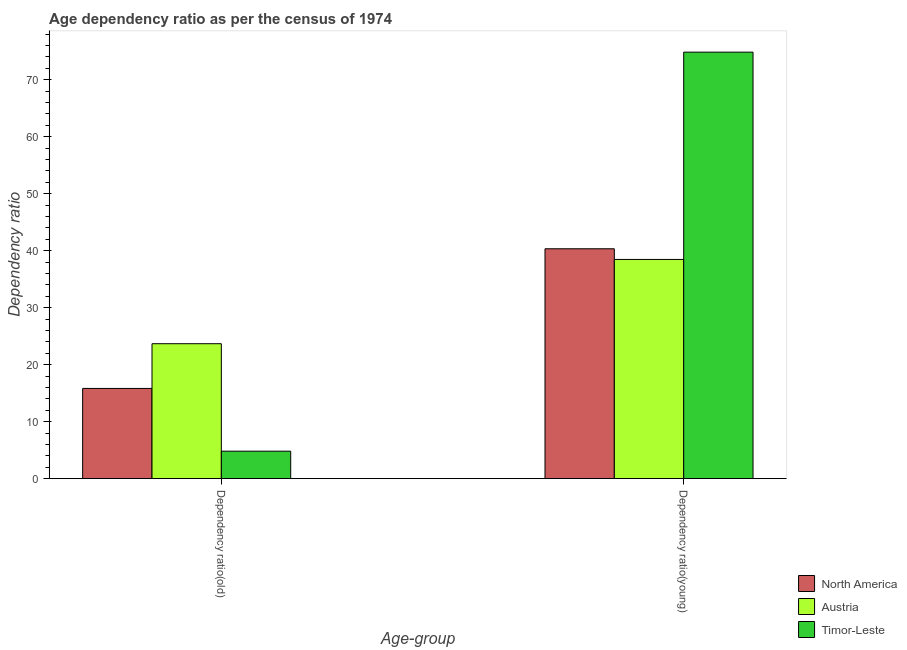How many different coloured bars are there?
Ensure brevity in your answer.  3. How many groups of bars are there?
Offer a terse response. 2. What is the label of the 2nd group of bars from the left?
Offer a terse response. Dependency ratio(young). What is the age dependency ratio(old) in North America?
Your answer should be compact. 15.83. Across all countries, what is the maximum age dependency ratio(young)?
Ensure brevity in your answer.  74.84. Across all countries, what is the minimum age dependency ratio(young)?
Keep it short and to the point. 38.46. What is the total age dependency ratio(old) in the graph?
Keep it short and to the point. 44.31. What is the difference between the age dependency ratio(old) in North America and that in Timor-Leste?
Provide a short and direct response. 11.01. What is the difference between the age dependency ratio(old) in Austria and the age dependency ratio(young) in Timor-Leste?
Give a very brief answer. -51.16. What is the average age dependency ratio(old) per country?
Your response must be concise. 14.77. What is the difference between the age dependency ratio(young) and age dependency ratio(old) in Austria?
Offer a terse response. 14.79. What is the ratio of the age dependency ratio(old) in Timor-Leste to that in North America?
Give a very brief answer. 0.3. Is the age dependency ratio(young) in Timor-Leste less than that in North America?
Provide a succinct answer. No. In how many countries, is the age dependency ratio(young) greater than the average age dependency ratio(young) taken over all countries?
Your answer should be compact. 1. What does the 1st bar from the right in Dependency ratio(old) represents?
Ensure brevity in your answer.  Timor-Leste. How many countries are there in the graph?
Your answer should be compact. 3. What is the difference between two consecutive major ticks on the Y-axis?
Ensure brevity in your answer.  10. Does the graph contain grids?
Your answer should be very brief. No. What is the title of the graph?
Your answer should be compact. Age dependency ratio as per the census of 1974. What is the label or title of the X-axis?
Your answer should be compact. Age-group. What is the label or title of the Y-axis?
Your answer should be very brief. Dependency ratio. What is the Dependency ratio in North America in Dependency ratio(old)?
Provide a succinct answer. 15.83. What is the Dependency ratio of Austria in Dependency ratio(old)?
Provide a succinct answer. 23.67. What is the Dependency ratio in Timor-Leste in Dependency ratio(old)?
Your answer should be compact. 4.81. What is the Dependency ratio in North America in Dependency ratio(young)?
Make the answer very short. 40.33. What is the Dependency ratio in Austria in Dependency ratio(young)?
Offer a terse response. 38.46. What is the Dependency ratio of Timor-Leste in Dependency ratio(young)?
Offer a terse response. 74.84. Across all Age-group, what is the maximum Dependency ratio of North America?
Keep it short and to the point. 40.33. Across all Age-group, what is the maximum Dependency ratio of Austria?
Ensure brevity in your answer.  38.46. Across all Age-group, what is the maximum Dependency ratio of Timor-Leste?
Give a very brief answer. 74.84. Across all Age-group, what is the minimum Dependency ratio of North America?
Your answer should be compact. 15.83. Across all Age-group, what is the minimum Dependency ratio in Austria?
Offer a very short reply. 23.67. Across all Age-group, what is the minimum Dependency ratio in Timor-Leste?
Give a very brief answer. 4.81. What is the total Dependency ratio in North America in the graph?
Your answer should be compact. 56.16. What is the total Dependency ratio of Austria in the graph?
Your answer should be very brief. 62.13. What is the total Dependency ratio of Timor-Leste in the graph?
Your response must be concise. 79.65. What is the difference between the Dependency ratio of North America in Dependency ratio(old) and that in Dependency ratio(young)?
Offer a terse response. -24.5. What is the difference between the Dependency ratio in Austria in Dependency ratio(old) and that in Dependency ratio(young)?
Your response must be concise. -14.79. What is the difference between the Dependency ratio in Timor-Leste in Dependency ratio(old) and that in Dependency ratio(young)?
Keep it short and to the point. -70.02. What is the difference between the Dependency ratio in North America in Dependency ratio(old) and the Dependency ratio in Austria in Dependency ratio(young)?
Ensure brevity in your answer.  -22.63. What is the difference between the Dependency ratio of North America in Dependency ratio(old) and the Dependency ratio of Timor-Leste in Dependency ratio(young)?
Your answer should be compact. -59.01. What is the difference between the Dependency ratio of Austria in Dependency ratio(old) and the Dependency ratio of Timor-Leste in Dependency ratio(young)?
Provide a succinct answer. -51.16. What is the average Dependency ratio in North America per Age-group?
Offer a terse response. 28.08. What is the average Dependency ratio of Austria per Age-group?
Keep it short and to the point. 31.07. What is the average Dependency ratio in Timor-Leste per Age-group?
Give a very brief answer. 39.82. What is the difference between the Dependency ratio of North America and Dependency ratio of Austria in Dependency ratio(old)?
Your answer should be very brief. -7.85. What is the difference between the Dependency ratio in North America and Dependency ratio in Timor-Leste in Dependency ratio(old)?
Make the answer very short. 11.01. What is the difference between the Dependency ratio in Austria and Dependency ratio in Timor-Leste in Dependency ratio(old)?
Offer a terse response. 18.86. What is the difference between the Dependency ratio of North America and Dependency ratio of Austria in Dependency ratio(young)?
Make the answer very short. 1.87. What is the difference between the Dependency ratio of North America and Dependency ratio of Timor-Leste in Dependency ratio(young)?
Offer a very short reply. -34.5. What is the difference between the Dependency ratio of Austria and Dependency ratio of Timor-Leste in Dependency ratio(young)?
Provide a succinct answer. -36.38. What is the ratio of the Dependency ratio in North America in Dependency ratio(old) to that in Dependency ratio(young)?
Give a very brief answer. 0.39. What is the ratio of the Dependency ratio in Austria in Dependency ratio(old) to that in Dependency ratio(young)?
Make the answer very short. 0.62. What is the ratio of the Dependency ratio in Timor-Leste in Dependency ratio(old) to that in Dependency ratio(young)?
Provide a short and direct response. 0.06. What is the difference between the highest and the second highest Dependency ratio in North America?
Your answer should be very brief. 24.5. What is the difference between the highest and the second highest Dependency ratio in Austria?
Offer a terse response. 14.79. What is the difference between the highest and the second highest Dependency ratio in Timor-Leste?
Keep it short and to the point. 70.02. What is the difference between the highest and the lowest Dependency ratio of North America?
Your response must be concise. 24.5. What is the difference between the highest and the lowest Dependency ratio in Austria?
Keep it short and to the point. 14.79. What is the difference between the highest and the lowest Dependency ratio of Timor-Leste?
Ensure brevity in your answer.  70.02. 